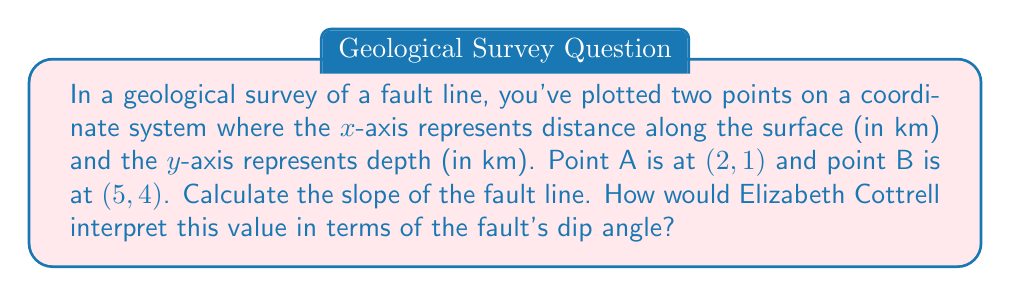Give your solution to this math problem. Let's approach this step-by-step:

1) The slope of a line can be calculated using the formula:

   $$m = \frac{y_2 - y_1}{x_2 - x_1}$$

   where $(x_1, y_1)$ and $(x_2, y_2)$ are two points on the line.

2) We have two points:
   A(2, 1) and B(5, 4)

3) Let's plug these into our formula:

   $$m = \frac{4 - 1}{5 - 2} = \frac{3}{3} = 1$$

4) The slope of the fault line is 1.

5) In geology, the slope of a fault line is related to its dip angle. The dip angle is the angle between the fault plane and a horizontal plane.

6) The relationship between slope (m) and dip angle (θ) is:

   $$\tan(\theta) = m$$

7) In this case, $\tan(\theta) = 1$

8) Taking the inverse tangent (arctan) of both sides:

   $$\theta = \arctan(1) = 45°$$

9) Elizabeth Cottrell, as a geochemist studying Earth's interior, would interpret this 45° dip angle as indicating a moderate to steep fault. This type of fault is often associated with significant vertical displacement and could be indicative of substantial tectonic activity in the area.

[asy]
unitsize(1cm);
draw((-1,0)--(6,0),arrow=Arrow(TeXHead));
draw((0,-1)--(0,5),arrow=Arrow(TeXHead));
draw((2,1)--(5,4),blue+1);
dot((2,1));
dot((5,4));
label("A(2,1)",(2,1),SW);
label("B(5,4)",(5,4),NE);
label("x (km)",5,-0.5);
label("y (km)",-0.5,5);
label("Fault line",3.5,3,NW);
[/asy]
Answer: Slope = 1; Dip angle = 45° 